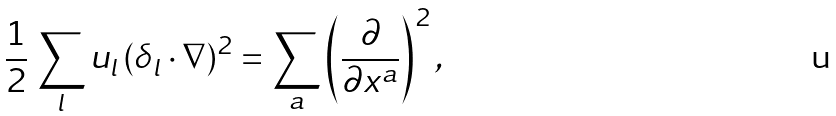<formula> <loc_0><loc_0><loc_500><loc_500>\frac { 1 } { 2 } \, \sum _ { l } u _ { l } \, ( \delta _ { l } \cdot \nabla ) ^ { 2 } = \sum _ { a } \left ( \frac { \partial } { \partial x ^ { a } } \right ) ^ { 2 } ,</formula> 